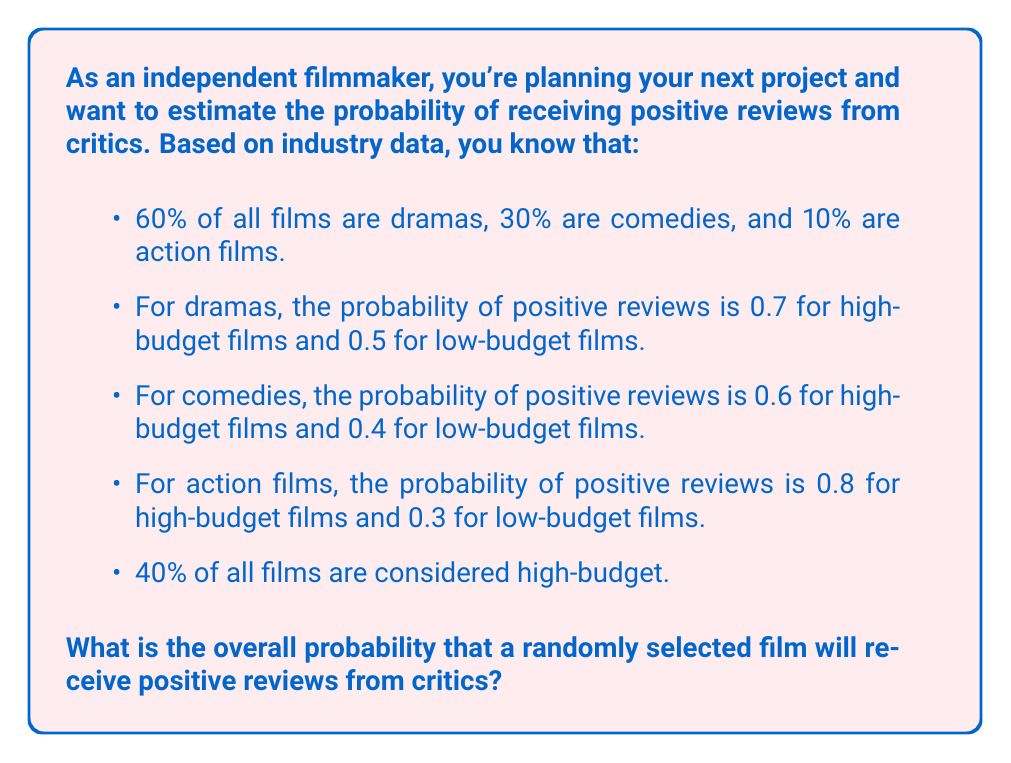Can you solve this math problem? To solve this problem, we'll use the law of total probability. Let's break it down step by step:

1) First, let's define our events:
   A: The film receives positive reviews
   H: The film is high-budget
   L: The film is low-budget
   D: Drama, C: Comedy, AC: Action

2) We need to calculate:
   $P(A) = P(A|D)P(D) + P(A|C)P(C) + P(A|AC)P(AC)$

3) For each genre, we need to consider both high and low budget films:
   $P(A|D) = P(A|D,H)P(H) + P(A|D,L)P(L)$
   $P(A|C) = P(A|C,H)P(H) + P(A|C,L)P(L)$
   $P(A|AC) = P(A|AC,H)P(H) + P(A|AC,L)P(L)$

4) We know that $P(H) = 0.4$ and $P(L) = 1 - 0.4 = 0.6$

5) Let's calculate for each genre:
   Drama: $P(A|D) = 0.7 * 0.4 + 0.5 * 0.6 = 0.28 + 0.30 = 0.58$
   Comedy: $P(A|C) = 0.6 * 0.4 + 0.4 * 0.6 = 0.24 + 0.24 = 0.48$
   Action: $P(A|AC) = 0.8 * 0.4 + 0.3 * 0.6 = 0.32 + 0.18 = 0.50$

6) Now we can calculate the overall probability:
   $P(A) = 0.58 * 0.6 + 0.48 * 0.3 + 0.50 * 0.1$
   $P(A) = 0.348 + 0.144 + 0.050 = 0.542$

Therefore, the overall probability that a randomly selected film will receive positive reviews is 0.542 or 54.2%.
Answer: 0.542 or 54.2% 